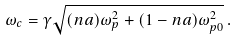Convert formula to latex. <formula><loc_0><loc_0><loc_500><loc_500>\omega _ { c } = \gamma \sqrt { ( n a ) \omega ^ { 2 } _ { p } + ( 1 - n a ) \omega ^ { 2 } _ { p 0 } } \, .</formula> 